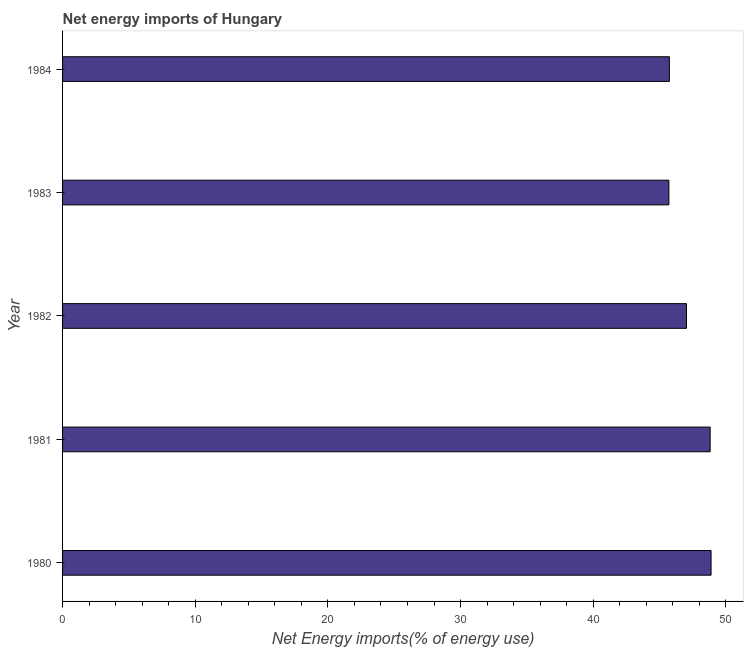Does the graph contain any zero values?
Offer a terse response. No. Does the graph contain grids?
Give a very brief answer. No. What is the title of the graph?
Ensure brevity in your answer.  Net energy imports of Hungary. What is the label or title of the X-axis?
Provide a succinct answer. Net Energy imports(% of energy use). What is the energy imports in 1983?
Keep it short and to the point. 45.7. Across all years, what is the maximum energy imports?
Provide a short and direct response. 48.88. Across all years, what is the minimum energy imports?
Provide a succinct answer. 45.7. In which year was the energy imports maximum?
Give a very brief answer. 1980. What is the sum of the energy imports?
Provide a short and direct response. 236.17. What is the difference between the energy imports in 1980 and 1981?
Your answer should be very brief. 0.07. What is the average energy imports per year?
Make the answer very short. 47.23. What is the median energy imports?
Your answer should be very brief. 47.03. Do a majority of the years between 1984 and 1982 (inclusive) have energy imports greater than 30 %?
Ensure brevity in your answer.  Yes. What is the ratio of the energy imports in 1980 to that in 1984?
Offer a terse response. 1.07. Is the difference between the energy imports in 1980 and 1982 greater than the difference between any two years?
Ensure brevity in your answer.  No. What is the difference between the highest and the second highest energy imports?
Your answer should be compact. 0.07. Is the sum of the energy imports in 1983 and 1984 greater than the maximum energy imports across all years?
Make the answer very short. Yes. What is the difference between the highest and the lowest energy imports?
Give a very brief answer. 3.18. How many years are there in the graph?
Keep it short and to the point. 5. What is the Net Energy imports(% of energy use) in 1980?
Provide a succinct answer. 48.88. What is the Net Energy imports(% of energy use) of 1981?
Provide a succinct answer. 48.81. What is the Net Energy imports(% of energy use) in 1982?
Offer a very short reply. 47.03. What is the Net Energy imports(% of energy use) in 1983?
Your answer should be very brief. 45.7. What is the Net Energy imports(% of energy use) of 1984?
Your response must be concise. 45.74. What is the difference between the Net Energy imports(% of energy use) in 1980 and 1981?
Your response must be concise. 0.07. What is the difference between the Net Energy imports(% of energy use) in 1980 and 1982?
Offer a very short reply. 1.85. What is the difference between the Net Energy imports(% of energy use) in 1980 and 1983?
Ensure brevity in your answer.  3.18. What is the difference between the Net Energy imports(% of energy use) in 1980 and 1984?
Ensure brevity in your answer.  3.14. What is the difference between the Net Energy imports(% of energy use) in 1981 and 1982?
Give a very brief answer. 1.78. What is the difference between the Net Energy imports(% of energy use) in 1981 and 1983?
Provide a succinct answer. 3.11. What is the difference between the Net Energy imports(% of energy use) in 1981 and 1984?
Make the answer very short. 3.07. What is the difference between the Net Energy imports(% of energy use) in 1982 and 1983?
Your response must be concise. 1.33. What is the difference between the Net Energy imports(% of energy use) in 1982 and 1984?
Provide a short and direct response. 1.29. What is the difference between the Net Energy imports(% of energy use) in 1983 and 1984?
Ensure brevity in your answer.  -0.04. What is the ratio of the Net Energy imports(% of energy use) in 1980 to that in 1982?
Ensure brevity in your answer.  1.04. What is the ratio of the Net Energy imports(% of energy use) in 1980 to that in 1983?
Ensure brevity in your answer.  1.07. What is the ratio of the Net Energy imports(% of energy use) in 1980 to that in 1984?
Offer a very short reply. 1.07. What is the ratio of the Net Energy imports(% of energy use) in 1981 to that in 1982?
Provide a succinct answer. 1.04. What is the ratio of the Net Energy imports(% of energy use) in 1981 to that in 1983?
Your answer should be very brief. 1.07. What is the ratio of the Net Energy imports(% of energy use) in 1981 to that in 1984?
Make the answer very short. 1.07. What is the ratio of the Net Energy imports(% of energy use) in 1982 to that in 1984?
Ensure brevity in your answer.  1.03. 